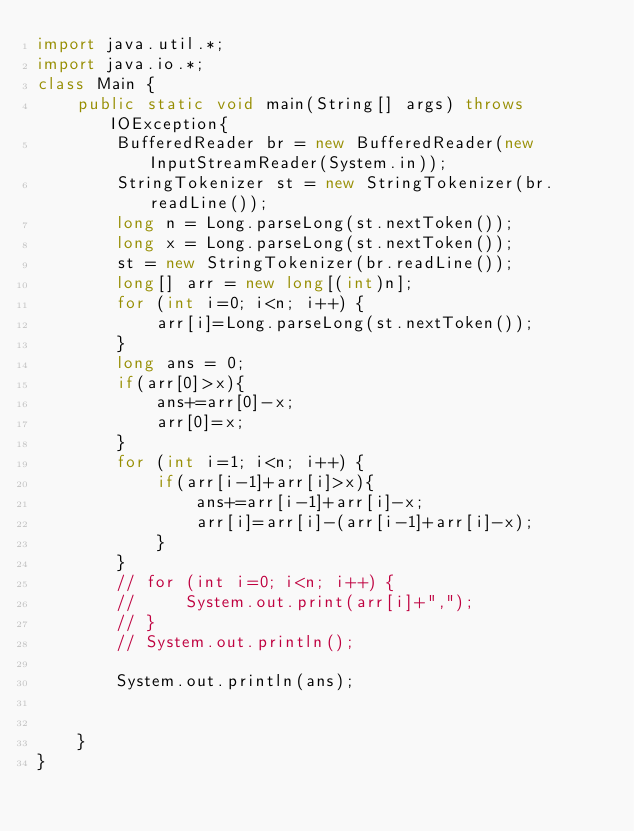Convert code to text. <code><loc_0><loc_0><loc_500><loc_500><_Java_>import java.util.*;
import java.io.*;
class Main {
    public static void main(String[] args) throws IOException{
        BufferedReader br = new BufferedReader(new InputStreamReader(System.in));
        StringTokenizer st = new StringTokenizer(br.readLine());
        long n = Long.parseLong(st.nextToken());
        long x = Long.parseLong(st.nextToken());
        st = new StringTokenizer(br.readLine());
        long[] arr = new long[(int)n];
        for (int i=0; i<n; i++) {
            arr[i]=Long.parseLong(st.nextToken());
        }
        long ans = 0;
        if(arr[0]>x){
            ans+=arr[0]-x;
            arr[0]=x;
        }
        for (int i=1; i<n; i++) {
            if(arr[i-1]+arr[i]>x){
                ans+=arr[i-1]+arr[i]-x;
                arr[i]=arr[i]-(arr[i-1]+arr[i]-x);
            }
        }
        // for (int i=0; i<n; i++) {
        //     System.out.print(arr[i]+",");
        // }
        // System.out.println();

        System.out.println(ans);

        
    }
}
</code> 